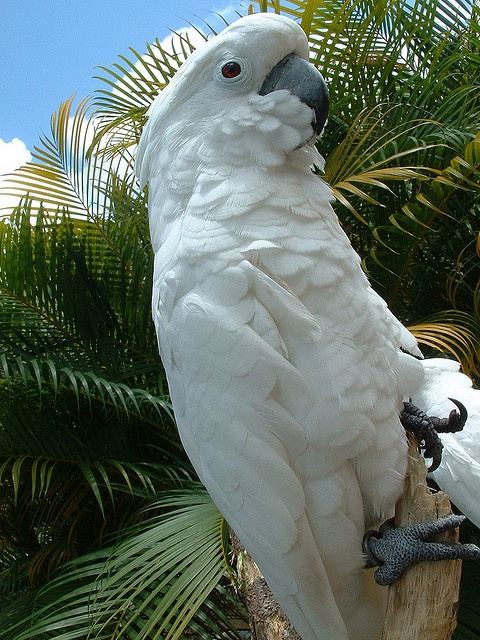Describe the objects in this image and their specific colors. I can see a bird in lightblue, darkgray, gray, and lightgray tones in this image. 